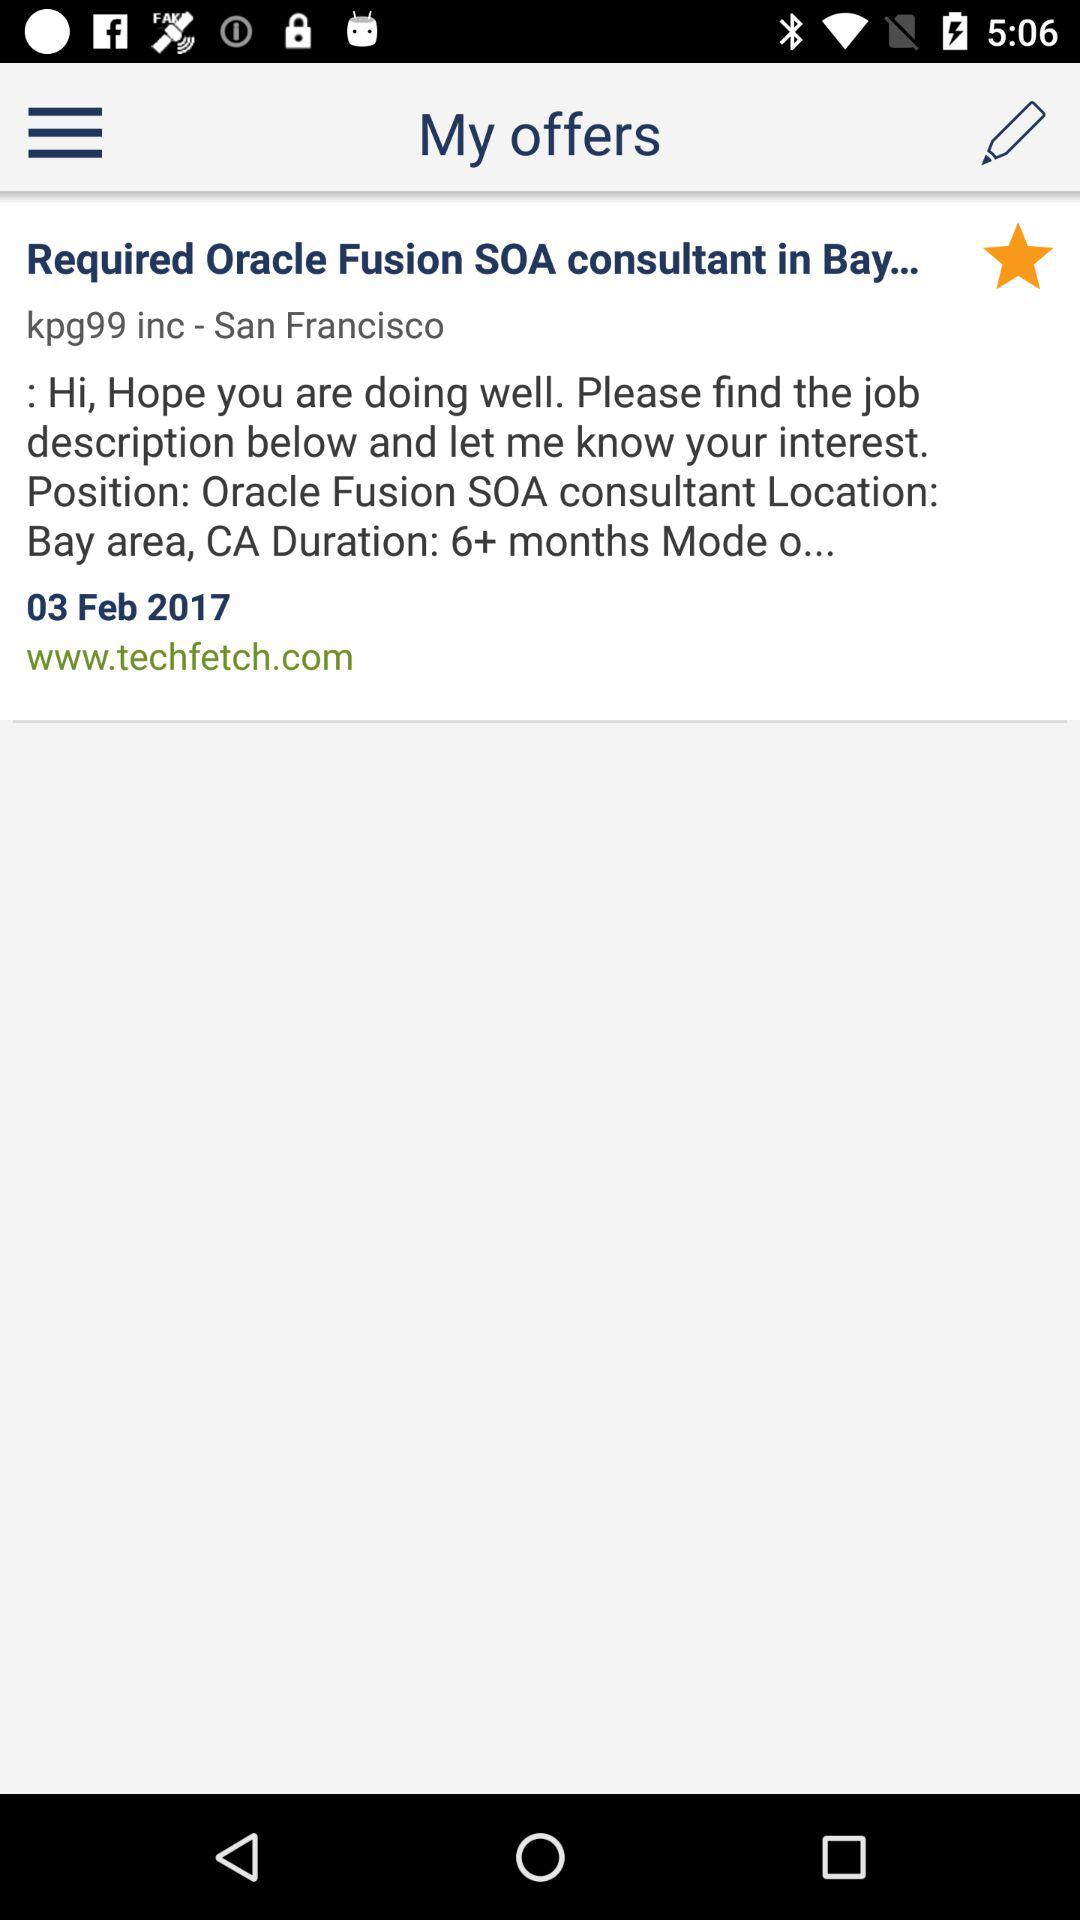What's the duration of CA? The duration is 6+ months. 